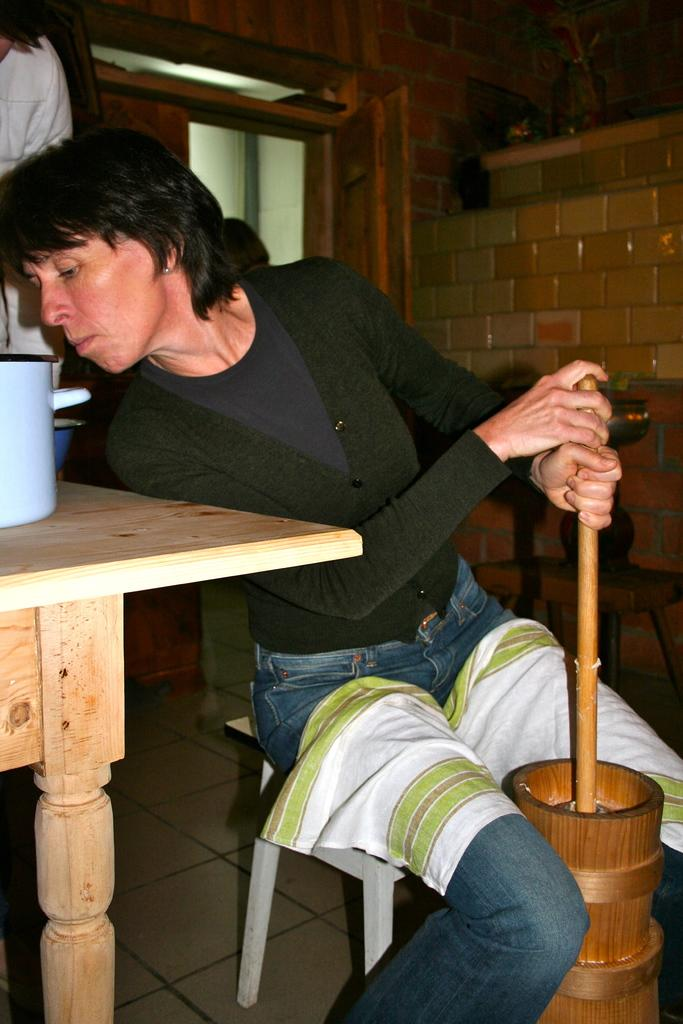What is the main subject of the image? There is a lady sitting on a chair in the center of the image. What is the lady holding in her hand? The lady is holding something in her hand. What is in front of the lady? There is a table in front of the lady. What can be seen in the background of the image? There is a brick wall in the background of the image. How many brothers does the lady have, and what are their names? There is no information about the lady's brothers in the image, so we cannot determine their names or number. What type of cake is on the table in the image? There is no cake present in the image; only a table can be seen. 